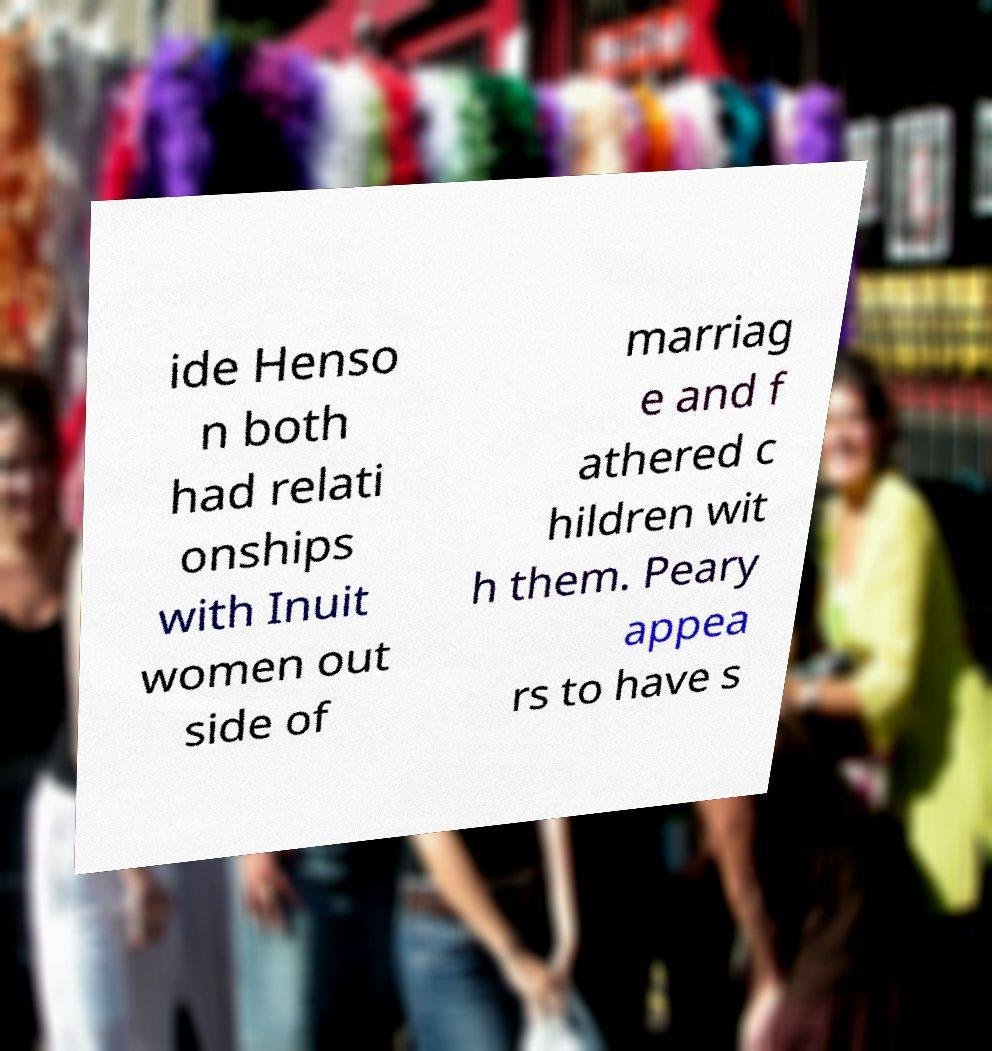Could you assist in decoding the text presented in this image and type it out clearly? ide Henso n both had relati onships with Inuit women out side of marriag e and f athered c hildren wit h them. Peary appea rs to have s 